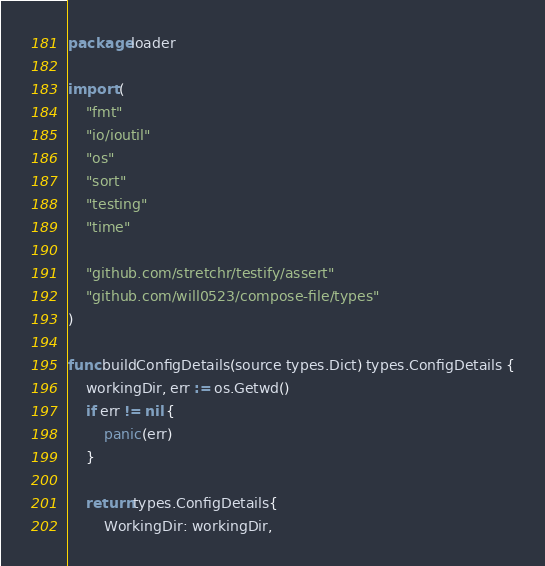<code> <loc_0><loc_0><loc_500><loc_500><_Go_>package loader

import (
	"fmt"
	"io/ioutil"
	"os"
	"sort"
	"testing"
	"time"

	"github.com/stretchr/testify/assert"
	"github.com/will0523/compose-file/types"
)

func buildConfigDetails(source types.Dict) types.ConfigDetails {
	workingDir, err := os.Getwd()
	if err != nil {
		panic(err)
	}

	return types.ConfigDetails{
		WorkingDir: workingDir,</code> 